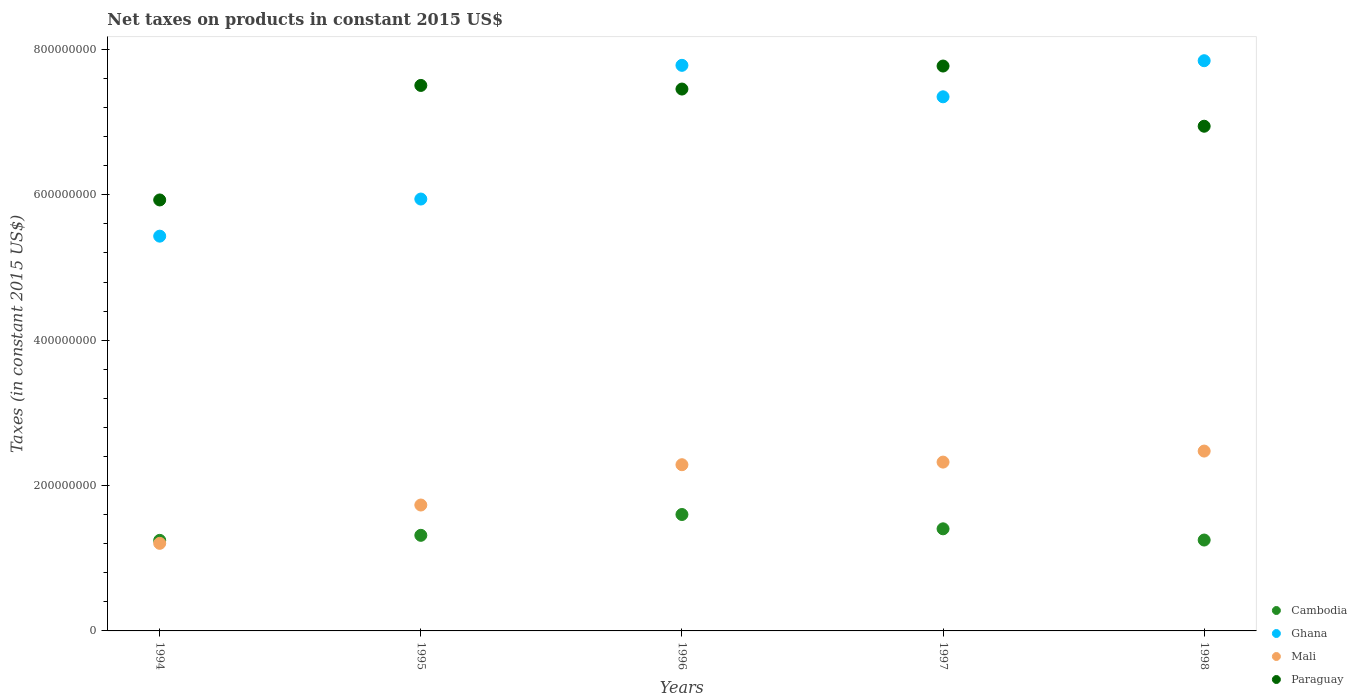How many different coloured dotlines are there?
Give a very brief answer. 4. What is the net taxes on products in Mali in 1997?
Your answer should be compact. 2.32e+08. Across all years, what is the maximum net taxes on products in Ghana?
Keep it short and to the point. 7.84e+08. Across all years, what is the minimum net taxes on products in Paraguay?
Offer a terse response. 5.93e+08. In which year was the net taxes on products in Cambodia maximum?
Offer a very short reply. 1996. In which year was the net taxes on products in Cambodia minimum?
Your answer should be compact. 1994. What is the total net taxes on products in Paraguay in the graph?
Your answer should be very brief. 3.56e+09. What is the difference between the net taxes on products in Ghana in 1995 and that in 1996?
Offer a very short reply. -1.84e+08. What is the difference between the net taxes on products in Ghana in 1994 and the net taxes on products in Paraguay in 1997?
Your response must be concise. -2.34e+08. What is the average net taxes on products in Ghana per year?
Provide a succinct answer. 6.87e+08. In the year 1995, what is the difference between the net taxes on products in Paraguay and net taxes on products in Cambodia?
Keep it short and to the point. 6.19e+08. In how many years, is the net taxes on products in Mali greater than 680000000 US$?
Offer a terse response. 0. What is the ratio of the net taxes on products in Cambodia in 1994 to that in 1996?
Provide a succinct answer. 0.78. Is the difference between the net taxes on products in Paraguay in 1997 and 1998 greater than the difference between the net taxes on products in Cambodia in 1997 and 1998?
Offer a very short reply. Yes. What is the difference between the highest and the second highest net taxes on products in Cambodia?
Give a very brief answer. 1.97e+07. What is the difference between the highest and the lowest net taxes on products in Paraguay?
Make the answer very short. 1.84e+08. Is it the case that in every year, the sum of the net taxes on products in Paraguay and net taxes on products in Ghana  is greater than the sum of net taxes on products in Cambodia and net taxes on products in Mali?
Provide a short and direct response. Yes. Is the net taxes on products in Ghana strictly greater than the net taxes on products in Cambodia over the years?
Give a very brief answer. Yes. Is the net taxes on products in Cambodia strictly less than the net taxes on products in Mali over the years?
Provide a succinct answer. No. How many dotlines are there?
Give a very brief answer. 4. How many years are there in the graph?
Provide a short and direct response. 5. Does the graph contain any zero values?
Ensure brevity in your answer.  No. Does the graph contain grids?
Your answer should be very brief. No. What is the title of the graph?
Ensure brevity in your answer.  Net taxes on products in constant 2015 US$. Does "Tajikistan" appear as one of the legend labels in the graph?
Ensure brevity in your answer.  No. What is the label or title of the X-axis?
Provide a short and direct response. Years. What is the label or title of the Y-axis?
Provide a short and direct response. Taxes (in constant 2015 US$). What is the Taxes (in constant 2015 US$) in Cambodia in 1994?
Give a very brief answer. 1.25e+08. What is the Taxes (in constant 2015 US$) in Ghana in 1994?
Ensure brevity in your answer.  5.43e+08. What is the Taxes (in constant 2015 US$) in Mali in 1994?
Your response must be concise. 1.20e+08. What is the Taxes (in constant 2015 US$) of Paraguay in 1994?
Your response must be concise. 5.93e+08. What is the Taxes (in constant 2015 US$) in Cambodia in 1995?
Offer a very short reply. 1.32e+08. What is the Taxes (in constant 2015 US$) of Ghana in 1995?
Keep it short and to the point. 5.94e+08. What is the Taxes (in constant 2015 US$) in Mali in 1995?
Your answer should be very brief. 1.73e+08. What is the Taxes (in constant 2015 US$) in Paraguay in 1995?
Give a very brief answer. 7.50e+08. What is the Taxes (in constant 2015 US$) in Cambodia in 1996?
Your answer should be very brief. 1.60e+08. What is the Taxes (in constant 2015 US$) in Ghana in 1996?
Make the answer very short. 7.78e+08. What is the Taxes (in constant 2015 US$) of Mali in 1996?
Your answer should be very brief. 2.29e+08. What is the Taxes (in constant 2015 US$) in Paraguay in 1996?
Make the answer very short. 7.45e+08. What is the Taxes (in constant 2015 US$) in Cambodia in 1997?
Provide a short and direct response. 1.40e+08. What is the Taxes (in constant 2015 US$) in Ghana in 1997?
Provide a short and direct response. 7.35e+08. What is the Taxes (in constant 2015 US$) of Mali in 1997?
Keep it short and to the point. 2.32e+08. What is the Taxes (in constant 2015 US$) in Paraguay in 1997?
Offer a terse response. 7.77e+08. What is the Taxes (in constant 2015 US$) in Cambodia in 1998?
Ensure brevity in your answer.  1.25e+08. What is the Taxes (in constant 2015 US$) in Ghana in 1998?
Offer a very short reply. 7.84e+08. What is the Taxes (in constant 2015 US$) of Mali in 1998?
Give a very brief answer. 2.47e+08. What is the Taxes (in constant 2015 US$) of Paraguay in 1998?
Make the answer very short. 6.94e+08. Across all years, what is the maximum Taxes (in constant 2015 US$) of Cambodia?
Your answer should be very brief. 1.60e+08. Across all years, what is the maximum Taxes (in constant 2015 US$) in Ghana?
Your response must be concise. 7.84e+08. Across all years, what is the maximum Taxes (in constant 2015 US$) in Mali?
Your response must be concise. 2.47e+08. Across all years, what is the maximum Taxes (in constant 2015 US$) in Paraguay?
Provide a succinct answer. 7.77e+08. Across all years, what is the minimum Taxes (in constant 2015 US$) of Cambodia?
Give a very brief answer. 1.25e+08. Across all years, what is the minimum Taxes (in constant 2015 US$) in Ghana?
Your answer should be compact. 5.43e+08. Across all years, what is the minimum Taxes (in constant 2015 US$) of Mali?
Your answer should be compact. 1.20e+08. Across all years, what is the minimum Taxes (in constant 2015 US$) of Paraguay?
Your answer should be very brief. 5.93e+08. What is the total Taxes (in constant 2015 US$) of Cambodia in the graph?
Offer a terse response. 6.82e+08. What is the total Taxes (in constant 2015 US$) in Ghana in the graph?
Ensure brevity in your answer.  3.43e+09. What is the total Taxes (in constant 2015 US$) in Mali in the graph?
Offer a terse response. 1.00e+09. What is the total Taxes (in constant 2015 US$) in Paraguay in the graph?
Ensure brevity in your answer.  3.56e+09. What is the difference between the Taxes (in constant 2015 US$) in Cambodia in 1994 and that in 1995?
Keep it short and to the point. -6.91e+06. What is the difference between the Taxes (in constant 2015 US$) of Ghana in 1994 and that in 1995?
Your response must be concise. -5.11e+07. What is the difference between the Taxes (in constant 2015 US$) of Mali in 1994 and that in 1995?
Offer a terse response. -5.27e+07. What is the difference between the Taxes (in constant 2015 US$) in Paraguay in 1994 and that in 1995?
Your answer should be very brief. -1.58e+08. What is the difference between the Taxes (in constant 2015 US$) in Cambodia in 1994 and that in 1996?
Give a very brief answer. -3.56e+07. What is the difference between the Taxes (in constant 2015 US$) of Ghana in 1994 and that in 1996?
Provide a succinct answer. -2.35e+08. What is the difference between the Taxes (in constant 2015 US$) in Mali in 1994 and that in 1996?
Your answer should be very brief. -1.08e+08. What is the difference between the Taxes (in constant 2015 US$) in Paraguay in 1994 and that in 1996?
Keep it short and to the point. -1.53e+08. What is the difference between the Taxes (in constant 2015 US$) of Cambodia in 1994 and that in 1997?
Ensure brevity in your answer.  -1.59e+07. What is the difference between the Taxes (in constant 2015 US$) of Ghana in 1994 and that in 1997?
Offer a terse response. -1.92e+08. What is the difference between the Taxes (in constant 2015 US$) in Mali in 1994 and that in 1997?
Give a very brief answer. -1.12e+08. What is the difference between the Taxes (in constant 2015 US$) of Paraguay in 1994 and that in 1997?
Keep it short and to the point. -1.84e+08. What is the difference between the Taxes (in constant 2015 US$) of Cambodia in 1994 and that in 1998?
Make the answer very short. -4.28e+05. What is the difference between the Taxes (in constant 2015 US$) in Ghana in 1994 and that in 1998?
Your answer should be very brief. -2.41e+08. What is the difference between the Taxes (in constant 2015 US$) in Mali in 1994 and that in 1998?
Offer a terse response. -1.27e+08. What is the difference between the Taxes (in constant 2015 US$) of Paraguay in 1994 and that in 1998?
Your response must be concise. -1.01e+08. What is the difference between the Taxes (in constant 2015 US$) in Cambodia in 1995 and that in 1996?
Offer a very short reply. -2.86e+07. What is the difference between the Taxes (in constant 2015 US$) of Ghana in 1995 and that in 1996?
Offer a very short reply. -1.84e+08. What is the difference between the Taxes (in constant 2015 US$) of Mali in 1995 and that in 1996?
Make the answer very short. -5.54e+07. What is the difference between the Taxes (in constant 2015 US$) in Paraguay in 1995 and that in 1996?
Your answer should be compact. 4.98e+06. What is the difference between the Taxes (in constant 2015 US$) in Cambodia in 1995 and that in 1997?
Your answer should be compact. -8.95e+06. What is the difference between the Taxes (in constant 2015 US$) in Ghana in 1995 and that in 1997?
Keep it short and to the point. -1.41e+08. What is the difference between the Taxes (in constant 2015 US$) of Mali in 1995 and that in 1997?
Offer a very short reply. -5.90e+07. What is the difference between the Taxes (in constant 2015 US$) of Paraguay in 1995 and that in 1997?
Your answer should be very brief. -2.67e+07. What is the difference between the Taxes (in constant 2015 US$) of Cambodia in 1995 and that in 1998?
Offer a terse response. 6.48e+06. What is the difference between the Taxes (in constant 2015 US$) in Ghana in 1995 and that in 1998?
Give a very brief answer. -1.90e+08. What is the difference between the Taxes (in constant 2015 US$) of Mali in 1995 and that in 1998?
Your response must be concise. -7.42e+07. What is the difference between the Taxes (in constant 2015 US$) of Paraguay in 1995 and that in 1998?
Offer a terse response. 5.61e+07. What is the difference between the Taxes (in constant 2015 US$) in Cambodia in 1996 and that in 1997?
Provide a short and direct response. 1.97e+07. What is the difference between the Taxes (in constant 2015 US$) of Ghana in 1996 and that in 1997?
Ensure brevity in your answer.  4.33e+07. What is the difference between the Taxes (in constant 2015 US$) in Mali in 1996 and that in 1997?
Provide a succinct answer. -3.59e+06. What is the difference between the Taxes (in constant 2015 US$) of Paraguay in 1996 and that in 1997?
Your answer should be very brief. -3.17e+07. What is the difference between the Taxes (in constant 2015 US$) in Cambodia in 1996 and that in 1998?
Make the answer very short. 3.51e+07. What is the difference between the Taxes (in constant 2015 US$) of Ghana in 1996 and that in 1998?
Make the answer very short. -6.37e+06. What is the difference between the Taxes (in constant 2015 US$) of Mali in 1996 and that in 1998?
Give a very brief answer. -1.88e+07. What is the difference between the Taxes (in constant 2015 US$) in Paraguay in 1996 and that in 1998?
Your response must be concise. 5.12e+07. What is the difference between the Taxes (in constant 2015 US$) of Cambodia in 1997 and that in 1998?
Offer a terse response. 1.54e+07. What is the difference between the Taxes (in constant 2015 US$) of Ghana in 1997 and that in 1998?
Ensure brevity in your answer.  -4.97e+07. What is the difference between the Taxes (in constant 2015 US$) of Mali in 1997 and that in 1998?
Make the answer very short. -1.52e+07. What is the difference between the Taxes (in constant 2015 US$) of Paraguay in 1997 and that in 1998?
Your answer should be very brief. 8.28e+07. What is the difference between the Taxes (in constant 2015 US$) of Cambodia in 1994 and the Taxes (in constant 2015 US$) of Ghana in 1995?
Your answer should be compact. -4.70e+08. What is the difference between the Taxes (in constant 2015 US$) of Cambodia in 1994 and the Taxes (in constant 2015 US$) of Mali in 1995?
Your answer should be very brief. -4.86e+07. What is the difference between the Taxes (in constant 2015 US$) of Cambodia in 1994 and the Taxes (in constant 2015 US$) of Paraguay in 1995?
Offer a terse response. -6.26e+08. What is the difference between the Taxes (in constant 2015 US$) in Ghana in 1994 and the Taxes (in constant 2015 US$) in Mali in 1995?
Ensure brevity in your answer.  3.70e+08. What is the difference between the Taxes (in constant 2015 US$) of Ghana in 1994 and the Taxes (in constant 2015 US$) of Paraguay in 1995?
Your answer should be compact. -2.07e+08. What is the difference between the Taxes (in constant 2015 US$) of Mali in 1994 and the Taxes (in constant 2015 US$) of Paraguay in 1995?
Your response must be concise. -6.30e+08. What is the difference between the Taxes (in constant 2015 US$) in Cambodia in 1994 and the Taxes (in constant 2015 US$) in Ghana in 1996?
Give a very brief answer. -6.53e+08. What is the difference between the Taxes (in constant 2015 US$) of Cambodia in 1994 and the Taxes (in constant 2015 US$) of Mali in 1996?
Make the answer very short. -1.04e+08. What is the difference between the Taxes (in constant 2015 US$) in Cambodia in 1994 and the Taxes (in constant 2015 US$) in Paraguay in 1996?
Your answer should be very brief. -6.21e+08. What is the difference between the Taxes (in constant 2015 US$) in Ghana in 1994 and the Taxes (in constant 2015 US$) in Mali in 1996?
Provide a short and direct response. 3.14e+08. What is the difference between the Taxes (in constant 2015 US$) in Ghana in 1994 and the Taxes (in constant 2015 US$) in Paraguay in 1996?
Keep it short and to the point. -2.02e+08. What is the difference between the Taxes (in constant 2015 US$) of Mali in 1994 and the Taxes (in constant 2015 US$) of Paraguay in 1996?
Make the answer very short. -6.25e+08. What is the difference between the Taxes (in constant 2015 US$) of Cambodia in 1994 and the Taxes (in constant 2015 US$) of Ghana in 1997?
Your answer should be compact. -6.10e+08. What is the difference between the Taxes (in constant 2015 US$) in Cambodia in 1994 and the Taxes (in constant 2015 US$) in Mali in 1997?
Make the answer very short. -1.08e+08. What is the difference between the Taxes (in constant 2015 US$) of Cambodia in 1994 and the Taxes (in constant 2015 US$) of Paraguay in 1997?
Offer a very short reply. -6.53e+08. What is the difference between the Taxes (in constant 2015 US$) in Ghana in 1994 and the Taxes (in constant 2015 US$) in Mali in 1997?
Provide a succinct answer. 3.11e+08. What is the difference between the Taxes (in constant 2015 US$) of Ghana in 1994 and the Taxes (in constant 2015 US$) of Paraguay in 1997?
Your response must be concise. -2.34e+08. What is the difference between the Taxes (in constant 2015 US$) of Mali in 1994 and the Taxes (in constant 2015 US$) of Paraguay in 1997?
Ensure brevity in your answer.  -6.57e+08. What is the difference between the Taxes (in constant 2015 US$) of Cambodia in 1994 and the Taxes (in constant 2015 US$) of Ghana in 1998?
Keep it short and to the point. -6.60e+08. What is the difference between the Taxes (in constant 2015 US$) in Cambodia in 1994 and the Taxes (in constant 2015 US$) in Mali in 1998?
Make the answer very short. -1.23e+08. What is the difference between the Taxes (in constant 2015 US$) in Cambodia in 1994 and the Taxes (in constant 2015 US$) in Paraguay in 1998?
Your response must be concise. -5.70e+08. What is the difference between the Taxes (in constant 2015 US$) of Ghana in 1994 and the Taxes (in constant 2015 US$) of Mali in 1998?
Keep it short and to the point. 2.96e+08. What is the difference between the Taxes (in constant 2015 US$) in Ghana in 1994 and the Taxes (in constant 2015 US$) in Paraguay in 1998?
Provide a succinct answer. -1.51e+08. What is the difference between the Taxes (in constant 2015 US$) of Mali in 1994 and the Taxes (in constant 2015 US$) of Paraguay in 1998?
Provide a short and direct response. -5.74e+08. What is the difference between the Taxes (in constant 2015 US$) in Cambodia in 1995 and the Taxes (in constant 2015 US$) in Ghana in 1996?
Give a very brief answer. -6.47e+08. What is the difference between the Taxes (in constant 2015 US$) of Cambodia in 1995 and the Taxes (in constant 2015 US$) of Mali in 1996?
Offer a very short reply. -9.71e+07. What is the difference between the Taxes (in constant 2015 US$) in Cambodia in 1995 and the Taxes (in constant 2015 US$) in Paraguay in 1996?
Your answer should be very brief. -6.14e+08. What is the difference between the Taxes (in constant 2015 US$) of Ghana in 1995 and the Taxes (in constant 2015 US$) of Mali in 1996?
Offer a terse response. 3.66e+08. What is the difference between the Taxes (in constant 2015 US$) of Ghana in 1995 and the Taxes (in constant 2015 US$) of Paraguay in 1996?
Your answer should be compact. -1.51e+08. What is the difference between the Taxes (in constant 2015 US$) in Mali in 1995 and the Taxes (in constant 2015 US$) in Paraguay in 1996?
Make the answer very short. -5.72e+08. What is the difference between the Taxes (in constant 2015 US$) in Cambodia in 1995 and the Taxes (in constant 2015 US$) in Ghana in 1997?
Give a very brief answer. -6.03e+08. What is the difference between the Taxes (in constant 2015 US$) in Cambodia in 1995 and the Taxes (in constant 2015 US$) in Mali in 1997?
Ensure brevity in your answer.  -1.01e+08. What is the difference between the Taxes (in constant 2015 US$) in Cambodia in 1995 and the Taxes (in constant 2015 US$) in Paraguay in 1997?
Give a very brief answer. -6.46e+08. What is the difference between the Taxes (in constant 2015 US$) in Ghana in 1995 and the Taxes (in constant 2015 US$) in Mali in 1997?
Your answer should be compact. 3.62e+08. What is the difference between the Taxes (in constant 2015 US$) in Ghana in 1995 and the Taxes (in constant 2015 US$) in Paraguay in 1997?
Give a very brief answer. -1.83e+08. What is the difference between the Taxes (in constant 2015 US$) of Mali in 1995 and the Taxes (in constant 2015 US$) of Paraguay in 1997?
Your response must be concise. -6.04e+08. What is the difference between the Taxes (in constant 2015 US$) of Cambodia in 1995 and the Taxes (in constant 2015 US$) of Ghana in 1998?
Make the answer very short. -6.53e+08. What is the difference between the Taxes (in constant 2015 US$) in Cambodia in 1995 and the Taxes (in constant 2015 US$) in Mali in 1998?
Your answer should be compact. -1.16e+08. What is the difference between the Taxes (in constant 2015 US$) of Cambodia in 1995 and the Taxes (in constant 2015 US$) of Paraguay in 1998?
Make the answer very short. -5.63e+08. What is the difference between the Taxes (in constant 2015 US$) in Ghana in 1995 and the Taxes (in constant 2015 US$) in Mali in 1998?
Your answer should be very brief. 3.47e+08. What is the difference between the Taxes (in constant 2015 US$) in Ghana in 1995 and the Taxes (in constant 2015 US$) in Paraguay in 1998?
Your response must be concise. -1.00e+08. What is the difference between the Taxes (in constant 2015 US$) in Mali in 1995 and the Taxes (in constant 2015 US$) in Paraguay in 1998?
Give a very brief answer. -5.21e+08. What is the difference between the Taxes (in constant 2015 US$) of Cambodia in 1996 and the Taxes (in constant 2015 US$) of Ghana in 1997?
Your response must be concise. -5.75e+08. What is the difference between the Taxes (in constant 2015 US$) of Cambodia in 1996 and the Taxes (in constant 2015 US$) of Mali in 1997?
Your response must be concise. -7.21e+07. What is the difference between the Taxes (in constant 2015 US$) of Cambodia in 1996 and the Taxes (in constant 2015 US$) of Paraguay in 1997?
Ensure brevity in your answer.  -6.17e+08. What is the difference between the Taxes (in constant 2015 US$) of Ghana in 1996 and the Taxes (in constant 2015 US$) of Mali in 1997?
Make the answer very short. 5.46e+08. What is the difference between the Taxes (in constant 2015 US$) of Ghana in 1996 and the Taxes (in constant 2015 US$) of Paraguay in 1997?
Your answer should be compact. 9.67e+05. What is the difference between the Taxes (in constant 2015 US$) in Mali in 1996 and the Taxes (in constant 2015 US$) in Paraguay in 1997?
Your response must be concise. -5.48e+08. What is the difference between the Taxes (in constant 2015 US$) in Cambodia in 1996 and the Taxes (in constant 2015 US$) in Ghana in 1998?
Ensure brevity in your answer.  -6.24e+08. What is the difference between the Taxes (in constant 2015 US$) in Cambodia in 1996 and the Taxes (in constant 2015 US$) in Mali in 1998?
Make the answer very short. -8.73e+07. What is the difference between the Taxes (in constant 2015 US$) in Cambodia in 1996 and the Taxes (in constant 2015 US$) in Paraguay in 1998?
Give a very brief answer. -5.34e+08. What is the difference between the Taxes (in constant 2015 US$) of Ghana in 1996 and the Taxes (in constant 2015 US$) of Mali in 1998?
Your answer should be compact. 5.31e+08. What is the difference between the Taxes (in constant 2015 US$) in Ghana in 1996 and the Taxes (in constant 2015 US$) in Paraguay in 1998?
Ensure brevity in your answer.  8.38e+07. What is the difference between the Taxes (in constant 2015 US$) in Mali in 1996 and the Taxes (in constant 2015 US$) in Paraguay in 1998?
Offer a terse response. -4.66e+08. What is the difference between the Taxes (in constant 2015 US$) in Cambodia in 1997 and the Taxes (in constant 2015 US$) in Ghana in 1998?
Make the answer very short. -6.44e+08. What is the difference between the Taxes (in constant 2015 US$) of Cambodia in 1997 and the Taxes (in constant 2015 US$) of Mali in 1998?
Ensure brevity in your answer.  -1.07e+08. What is the difference between the Taxes (in constant 2015 US$) in Cambodia in 1997 and the Taxes (in constant 2015 US$) in Paraguay in 1998?
Provide a short and direct response. -5.54e+08. What is the difference between the Taxes (in constant 2015 US$) of Ghana in 1997 and the Taxes (in constant 2015 US$) of Mali in 1998?
Provide a short and direct response. 4.87e+08. What is the difference between the Taxes (in constant 2015 US$) in Ghana in 1997 and the Taxes (in constant 2015 US$) in Paraguay in 1998?
Offer a very short reply. 4.05e+07. What is the difference between the Taxes (in constant 2015 US$) in Mali in 1997 and the Taxes (in constant 2015 US$) in Paraguay in 1998?
Your answer should be very brief. -4.62e+08. What is the average Taxes (in constant 2015 US$) in Cambodia per year?
Your answer should be compact. 1.36e+08. What is the average Taxes (in constant 2015 US$) of Ghana per year?
Provide a succinct answer. 6.87e+08. What is the average Taxes (in constant 2015 US$) of Mali per year?
Your answer should be compact. 2.00e+08. What is the average Taxes (in constant 2015 US$) of Paraguay per year?
Offer a very short reply. 7.12e+08. In the year 1994, what is the difference between the Taxes (in constant 2015 US$) in Cambodia and Taxes (in constant 2015 US$) in Ghana?
Ensure brevity in your answer.  -4.18e+08. In the year 1994, what is the difference between the Taxes (in constant 2015 US$) in Cambodia and Taxes (in constant 2015 US$) in Mali?
Ensure brevity in your answer.  4.12e+06. In the year 1994, what is the difference between the Taxes (in constant 2015 US$) in Cambodia and Taxes (in constant 2015 US$) in Paraguay?
Your answer should be compact. -4.68e+08. In the year 1994, what is the difference between the Taxes (in constant 2015 US$) of Ghana and Taxes (in constant 2015 US$) of Mali?
Provide a succinct answer. 4.23e+08. In the year 1994, what is the difference between the Taxes (in constant 2015 US$) of Ghana and Taxes (in constant 2015 US$) of Paraguay?
Give a very brief answer. -4.98e+07. In the year 1994, what is the difference between the Taxes (in constant 2015 US$) in Mali and Taxes (in constant 2015 US$) in Paraguay?
Ensure brevity in your answer.  -4.72e+08. In the year 1995, what is the difference between the Taxes (in constant 2015 US$) in Cambodia and Taxes (in constant 2015 US$) in Ghana?
Your response must be concise. -4.63e+08. In the year 1995, what is the difference between the Taxes (in constant 2015 US$) of Cambodia and Taxes (in constant 2015 US$) of Mali?
Your answer should be compact. -4.17e+07. In the year 1995, what is the difference between the Taxes (in constant 2015 US$) in Cambodia and Taxes (in constant 2015 US$) in Paraguay?
Make the answer very short. -6.19e+08. In the year 1995, what is the difference between the Taxes (in constant 2015 US$) in Ghana and Taxes (in constant 2015 US$) in Mali?
Your answer should be compact. 4.21e+08. In the year 1995, what is the difference between the Taxes (in constant 2015 US$) of Ghana and Taxes (in constant 2015 US$) of Paraguay?
Your answer should be very brief. -1.56e+08. In the year 1995, what is the difference between the Taxes (in constant 2015 US$) of Mali and Taxes (in constant 2015 US$) of Paraguay?
Keep it short and to the point. -5.77e+08. In the year 1996, what is the difference between the Taxes (in constant 2015 US$) of Cambodia and Taxes (in constant 2015 US$) of Ghana?
Provide a succinct answer. -6.18e+08. In the year 1996, what is the difference between the Taxes (in constant 2015 US$) of Cambodia and Taxes (in constant 2015 US$) of Mali?
Offer a very short reply. -6.85e+07. In the year 1996, what is the difference between the Taxes (in constant 2015 US$) in Cambodia and Taxes (in constant 2015 US$) in Paraguay?
Offer a terse response. -5.85e+08. In the year 1996, what is the difference between the Taxes (in constant 2015 US$) in Ghana and Taxes (in constant 2015 US$) in Mali?
Your response must be concise. 5.49e+08. In the year 1996, what is the difference between the Taxes (in constant 2015 US$) of Ghana and Taxes (in constant 2015 US$) of Paraguay?
Your answer should be compact. 3.26e+07. In the year 1996, what is the difference between the Taxes (in constant 2015 US$) in Mali and Taxes (in constant 2015 US$) in Paraguay?
Ensure brevity in your answer.  -5.17e+08. In the year 1997, what is the difference between the Taxes (in constant 2015 US$) in Cambodia and Taxes (in constant 2015 US$) in Ghana?
Provide a short and direct response. -5.94e+08. In the year 1997, what is the difference between the Taxes (in constant 2015 US$) in Cambodia and Taxes (in constant 2015 US$) in Mali?
Give a very brief answer. -9.18e+07. In the year 1997, what is the difference between the Taxes (in constant 2015 US$) of Cambodia and Taxes (in constant 2015 US$) of Paraguay?
Give a very brief answer. -6.37e+08. In the year 1997, what is the difference between the Taxes (in constant 2015 US$) in Ghana and Taxes (in constant 2015 US$) in Mali?
Offer a very short reply. 5.03e+08. In the year 1997, what is the difference between the Taxes (in constant 2015 US$) in Ghana and Taxes (in constant 2015 US$) in Paraguay?
Provide a succinct answer. -4.23e+07. In the year 1997, what is the difference between the Taxes (in constant 2015 US$) of Mali and Taxes (in constant 2015 US$) of Paraguay?
Provide a short and direct response. -5.45e+08. In the year 1998, what is the difference between the Taxes (in constant 2015 US$) in Cambodia and Taxes (in constant 2015 US$) in Ghana?
Provide a short and direct response. -6.59e+08. In the year 1998, what is the difference between the Taxes (in constant 2015 US$) of Cambodia and Taxes (in constant 2015 US$) of Mali?
Keep it short and to the point. -1.22e+08. In the year 1998, what is the difference between the Taxes (in constant 2015 US$) in Cambodia and Taxes (in constant 2015 US$) in Paraguay?
Your response must be concise. -5.69e+08. In the year 1998, what is the difference between the Taxes (in constant 2015 US$) of Ghana and Taxes (in constant 2015 US$) of Mali?
Offer a terse response. 5.37e+08. In the year 1998, what is the difference between the Taxes (in constant 2015 US$) in Ghana and Taxes (in constant 2015 US$) in Paraguay?
Make the answer very short. 9.01e+07. In the year 1998, what is the difference between the Taxes (in constant 2015 US$) in Mali and Taxes (in constant 2015 US$) in Paraguay?
Ensure brevity in your answer.  -4.47e+08. What is the ratio of the Taxes (in constant 2015 US$) in Ghana in 1994 to that in 1995?
Give a very brief answer. 0.91. What is the ratio of the Taxes (in constant 2015 US$) of Mali in 1994 to that in 1995?
Offer a very short reply. 0.7. What is the ratio of the Taxes (in constant 2015 US$) in Paraguay in 1994 to that in 1995?
Your response must be concise. 0.79. What is the ratio of the Taxes (in constant 2015 US$) of Cambodia in 1994 to that in 1996?
Provide a short and direct response. 0.78. What is the ratio of the Taxes (in constant 2015 US$) in Ghana in 1994 to that in 1996?
Offer a terse response. 0.7. What is the ratio of the Taxes (in constant 2015 US$) of Mali in 1994 to that in 1996?
Your answer should be very brief. 0.53. What is the ratio of the Taxes (in constant 2015 US$) in Paraguay in 1994 to that in 1996?
Provide a short and direct response. 0.8. What is the ratio of the Taxes (in constant 2015 US$) in Cambodia in 1994 to that in 1997?
Your answer should be compact. 0.89. What is the ratio of the Taxes (in constant 2015 US$) of Ghana in 1994 to that in 1997?
Provide a succinct answer. 0.74. What is the ratio of the Taxes (in constant 2015 US$) of Mali in 1994 to that in 1997?
Your response must be concise. 0.52. What is the ratio of the Taxes (in constant 2015 US$) in Paraguay in 1994 to that in 1997?
Your answer should be very brief. 0.76. What is the ratio of the Taxes (in constant 2015 US$) of Cambodia in 1994 to that in 1998?
Offer a very short reply. 1. What is the ratio of the Taxes (in constant 2015 US$) of Ghana in 1994 to that in 1998?
Offer a very short reply. 0.69. What is the ratio of the Taxes (in constant 2015 US$) of Mali in 1994 to that in 1998?
Your response must be concise. 0.49. What is the ratio of the Taxes (in constant 2015 US$) in Paraguay in 1994 to that in 1998?
Ensure brevity in your answer.  0.85. What is the ratio of the Taxes (in constant 2015 US$) of Cambodia in 1995 to that in 1996?
Give a very brief answer. 0.82. What is the ratio of the Taxes (in constant 2015 US$) of Ghana in 1995 to that in 1996?
Your answer should be compact. 0.76. What is the ratio of the Taxes (in constant 2015 US$) in Mali in 1995 to that in 1996?
Provide a succinct answer. 0.76. What is the ratio of the Taxes (in constant 2015 US$) in Cambodia in 1995 to that in 1997?
Offer a terse response. 0.94. What is the ratio of the Taxes (in constant 2015 US$) in Ghana in 1995 to that in 1997?
Provide a succinct answer. 0.81. What is the ratio of the Taxes (in constant 2015 US$) of Mali in 1995 to that in 1997?
Your answer should be very brief. 0.75. What is the ratio of the Taxes (in constant 2015 US$) in Paraguay in 1995 to that in 1997?
Offer a terse response. 0.97. What is the ratio of the Taxes (in constant 2015 US$) in Cambodia in 1995 to that in 1998?
Give a very brief answer. 1.05. What is the ratio of the Taxes (in constant 2015 US$) of Ghana in 1995 to that in 1998?
Your answer should be very brief. 0.76. What is the ratio of the Taxes (in constant 2015 US$) of Mali in 1995 to that in 1998?
Your response must be concise. 0.7. What is the ratio of the Taxes (in constant 2015 US$) of Paraguay in 1995 to that in 1998?
Provide a succinct answer. 1.08. What is the ratio of the Taxes (in constant 2015 US$) in Cambodia in 1996 to that in 1997?
Your response must be concise. 1.14. What is the ratio of the Taxes (in constant 2015 US$) in Ghana in 1996 to that in 1997?
Ensure brevity in your answer.  1.06. What is the ratio of the Taxes (in constant 2015 US$) in Mali in 1996 to that in 1997?
Offer a terse response. 0.98. What is the ratio of the Taxes (in constant 2015 US$) in Paraguay in 1996 to that in 1997?
Your response must be concise. 0.96. What is the ratio of the Taxes (in constant 2015 US$) in Cambodia in 1996 to that in 1998?
Make the answer very short. 1.28. What is the ratio of the Taxes (in constant 2015 US$) of Mali in 1996 to that in 1998?
Offer a terse response. 0.92. What is the ratio of the Taxes (in constant 2015 US$) of Paraguay in 1996 to that in 1998?
Make the answer very short. 1.07. What is the ratio of the Taxes (in constant 2015 US$) of Cambodia in 1997 to that in 1998?
Make the answer very short. 1.12. What is the ratio of the Taxes (in constant 2015 US$) in Ghana in 1997 to that in 1998?
Provide a succinct answer. 0.94. What is the ratio of the Taxes (in constant 2015 US$) of Mali in 1997 to that in 1998?
Offer a terse response. 0.94. What is the ratio of the Taxes (in constant 2015 US$) of Paraguay in 1997 to that in 1998?
Give a very brief answer. 1.12. What is the difference between the highest and the second highest Taxes (in constant 2015 US$) in Cambodia?
Keep it short and to the point. 1.97e+07. What is the difference between the highest and the second highest Taxes (in constant 2015 US$) in Ghana?
Your answer should be very brief. 6.37e+06. What is the difference between the highest and the second highest Taxes (in constant 2015 US$) in Mali?
Your response must be concise. 1.52e+07. What is the difference between the highest and the second highest Taxes (in constant 2015 US$) of Paraguay?
Your response must be concise. 2.67e+07. What is the difference between the highest and the lowest Taxes (in constant 2015 US$) of Cambodia?
Ensure brevity in your answer.  3.56e+07. What is the difference between the highest and the lowest Taxes (in constant 2015 US$) in Ghana?
Ensure brevity in your answer.  2.41e+08. What is the difference between the highest and the lowest Taxes (in constant 2015 US$) in Mali?
Your response must be concise. 1.27e+08. What is the difference between the highest and the lowest Taxes (in constant 2015 US$) in Paraguay?
Give a very brief answer. 1.84e+08. 